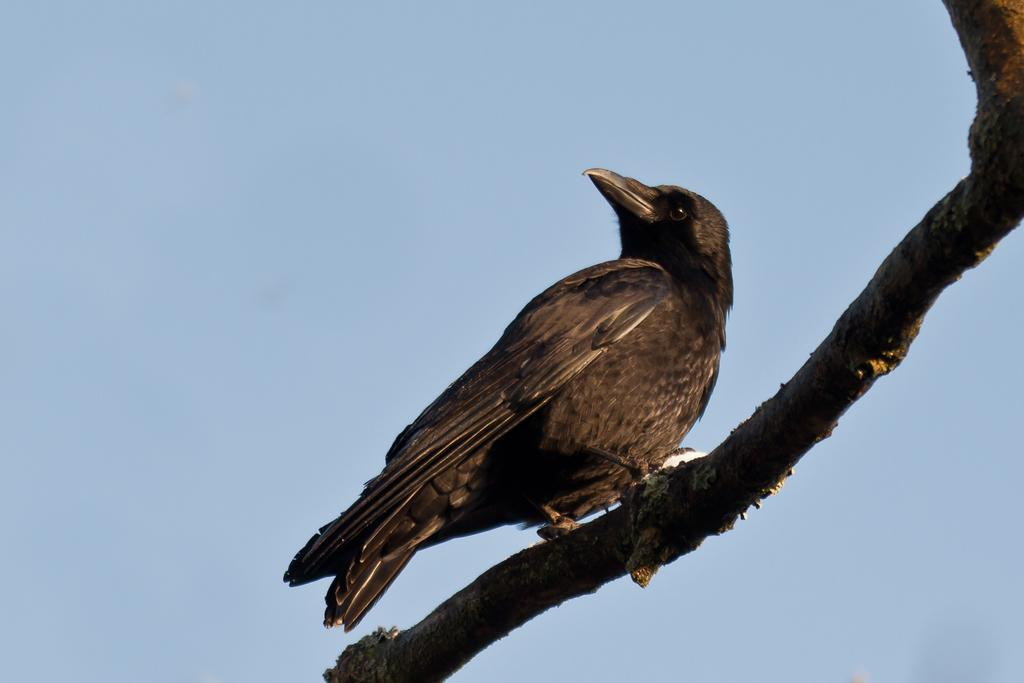What type of animal can be seen in the image? There is a bird in the image. Where is the bird located? The bird is on a branch. What can be seen in the background of the image? The sky is visible in the background of the image. How many chairs are visible in the image? There are no chairs present in the image. 